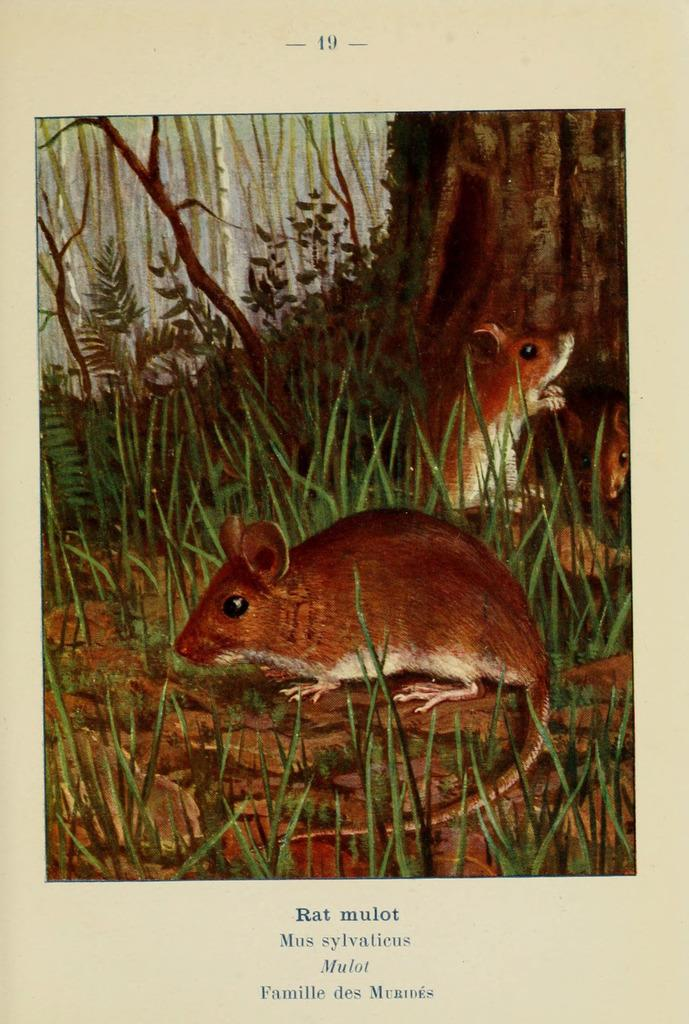What type of animals are present in the image? There are rats in the image. What type of vegetation can be seen in the image? There is grass, leaves, and branches in the image. Is there any text present in the image? Yes, there is text written at the bottom of the poster. Where is the faucet located in the image? There is no faucet present in the image. What type of business is being advertised in the image? The image does not depict a business or any advertisement. 